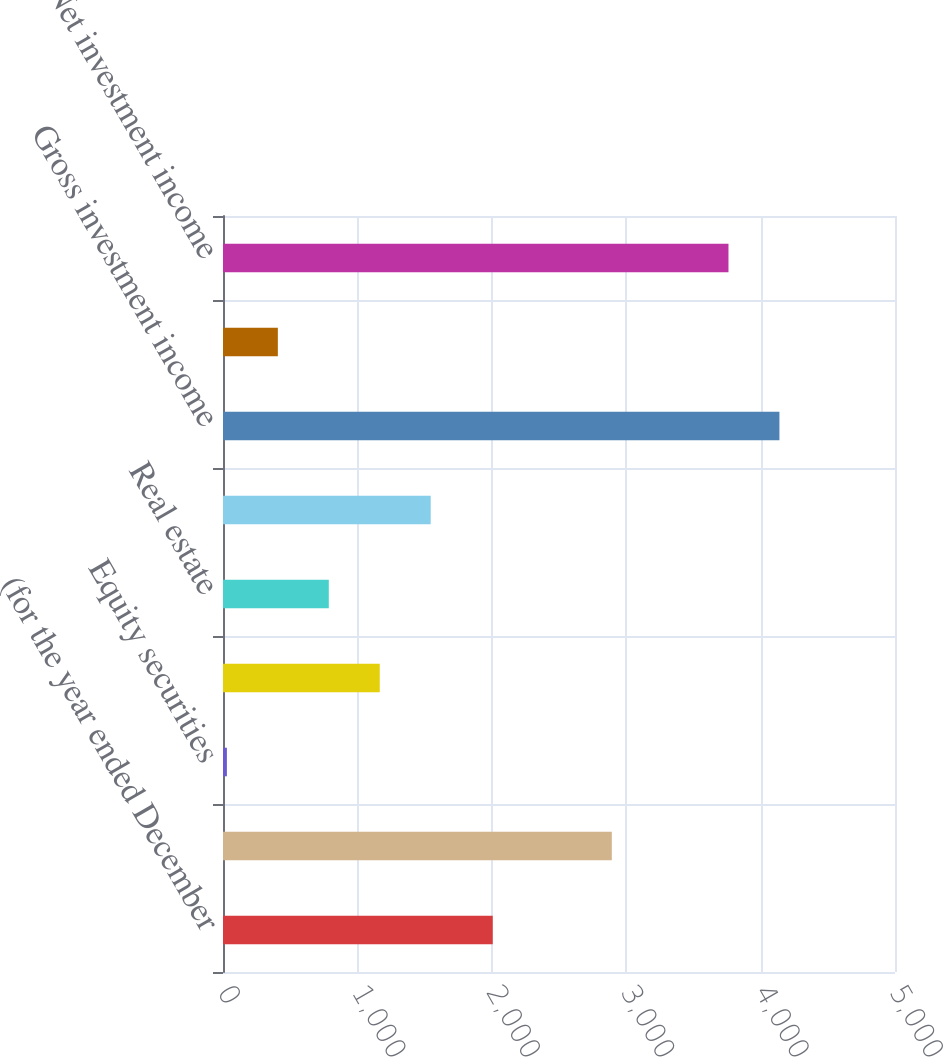Convert chart to OTSL. <chart><loc_0><loc_0><loc_500><loc_500><bar_chart><fcel>(for the year ended December<fcel>Fixed maturities<fcel>Equity securities<fcel>Short-term securities<fcel>Real estate<fcel>Other investments<fcel>Gross investment income<fcel>Investment expenses<fcel>Net investment income<nl><fcel>2007<fcel>2893<fcel>29<fcel>1166.3<fcel>787.2<fcel>1545.4<fcel>4140.1<fcel>408.1<fcel>3761<nl></chart> 